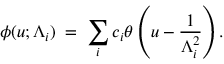Convert formula to latex. <formula><loc_0><loc_0><loc_500><loc_500>\phi ( u ; \Lambda _ { i } ) \, = \, \sum _ { i } c _ { i } \theta \left ( u - \frac { 1 } { \Lambda _ { i } ^ { 2 } } \right ) .</formula> 